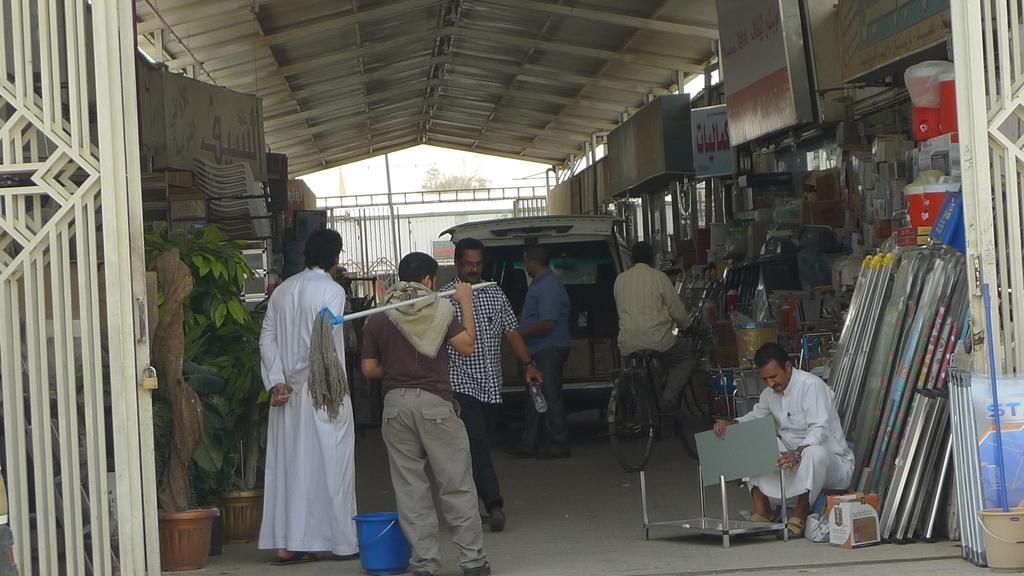Describe this image in one or two sentences. In this image I can see number of people where one is sitting and rest all are standing. I can also see one person is sitting on a bicycle. Here I can see a bucket, few plants in pots, few boards and on these boards I can see something is written. I can also see many other things over here and in the background can see a tree. 